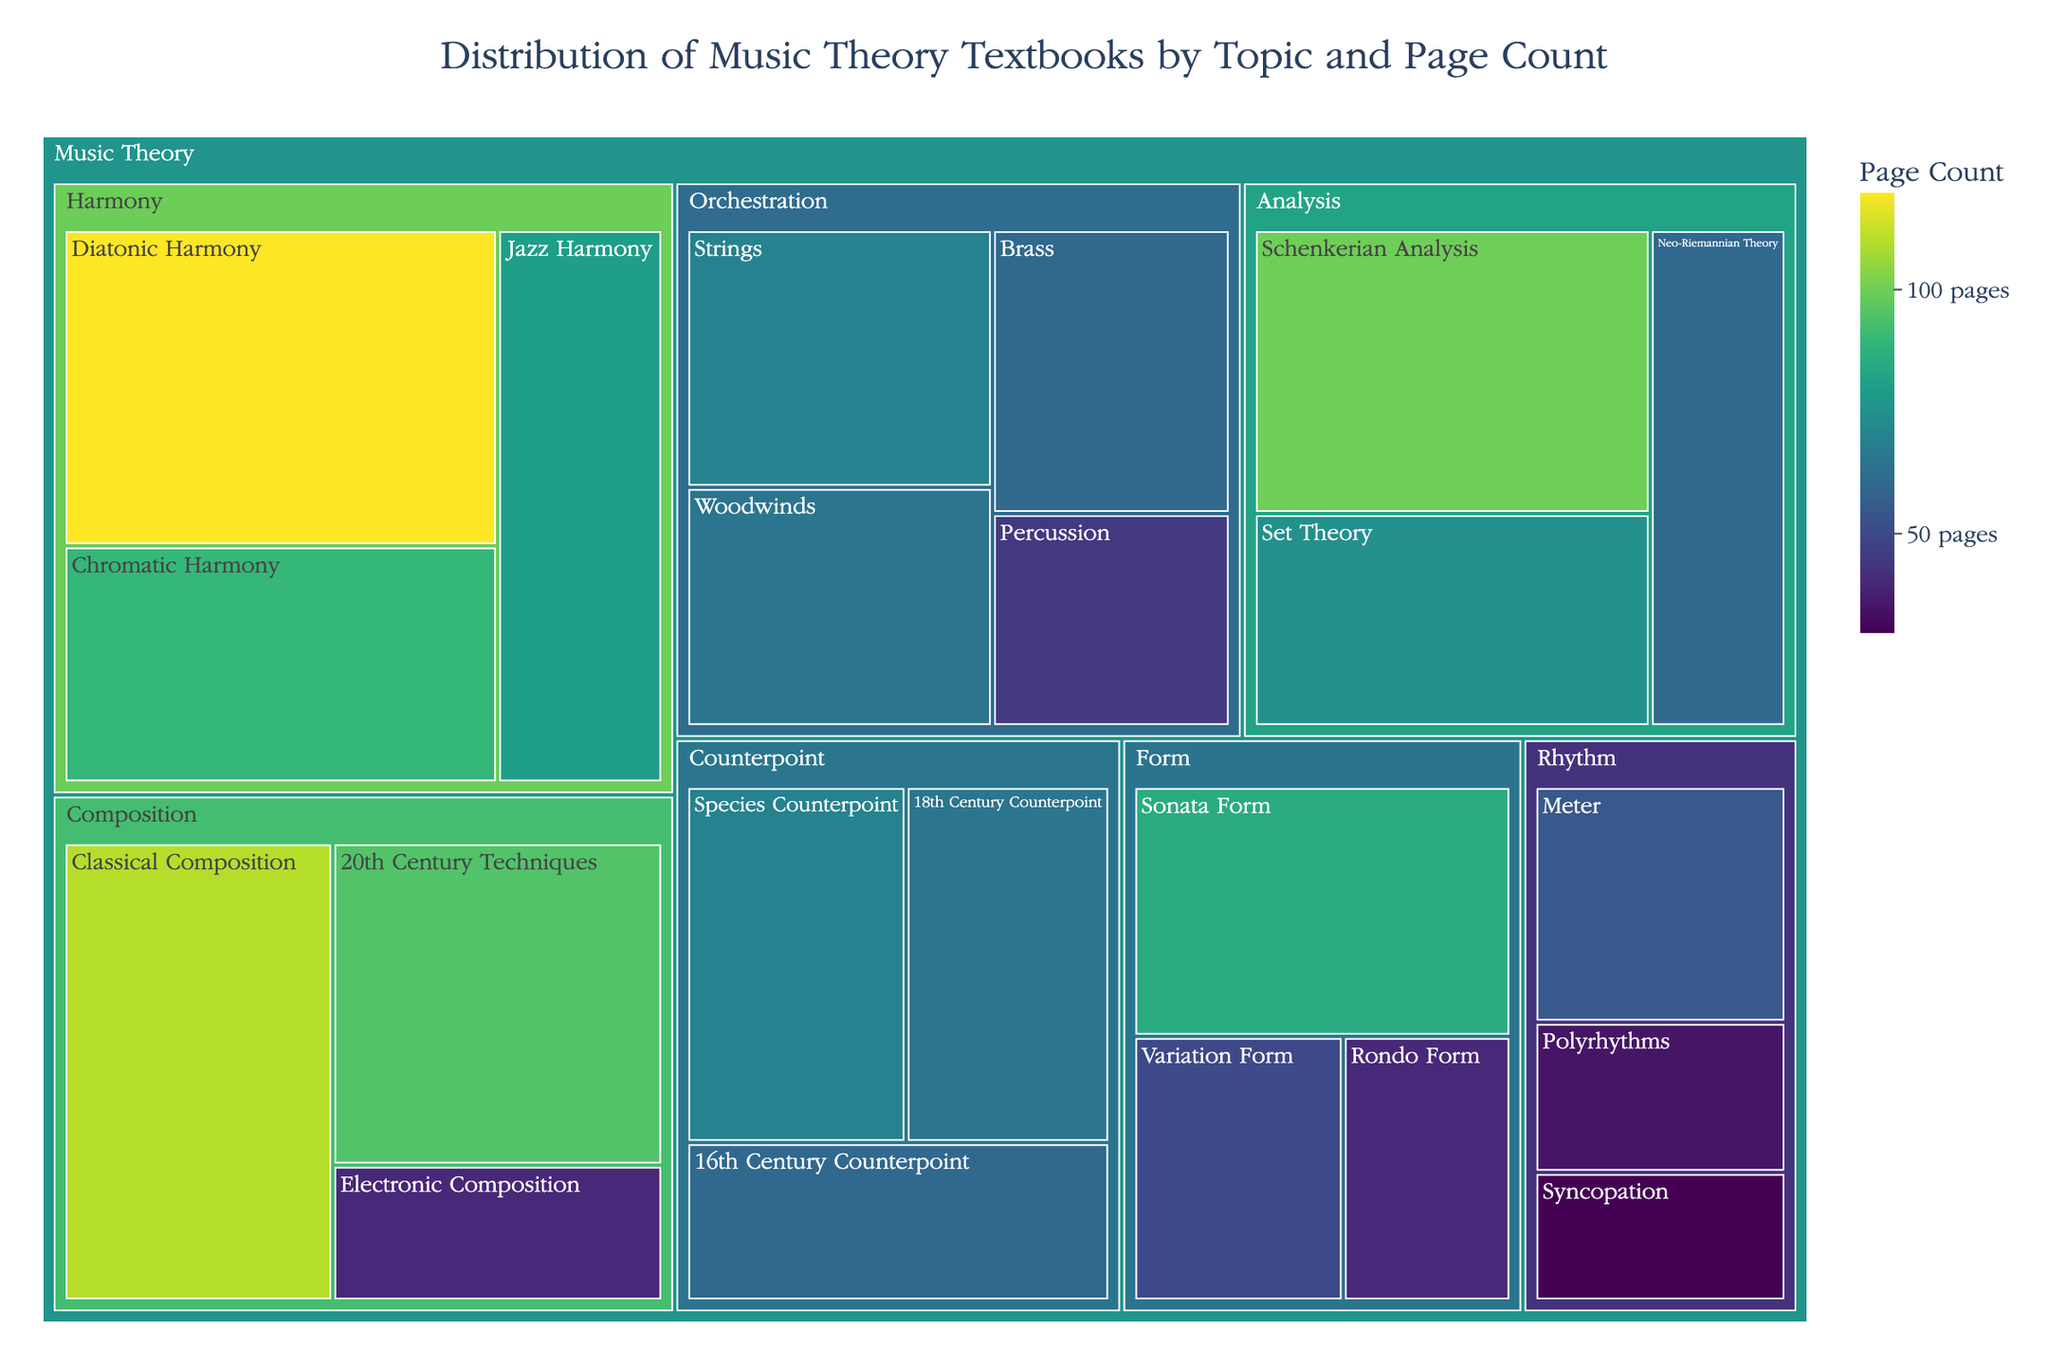What's the largest subtopic in terms of page count? First, look for the largest rectangle in the treemap. The largest one corresponds to "Diatonic Harmony" under the "Harmony" topic with 120 pages.
Answer: Diatonic Harmony Sum the page counts for all subtopics under "Harmony". Identify all subtopics under "Harmony". Add their page counts: 120 (Diatonic Harmony) + 90 (Chromatic Harmony) + 80 (Jazz Harmony) = 290 pages.
Answer: 290 pages Which subtopic has the fewest pages, and how many pages does it have? Look for the smallest rectangle in the treemap. "Syncopation" under "Rhythm" has the fewest pages, with 30 pages.
Answer: Syncopation, 30 pages Compare the total pages for "Counterpoint" and "Form". Which one has more pages? Sum the pages for each subtopic under "Counterpoint" and "Form". Counterpoint: 70 + 60 + 65 = 195 pages, Form: 85 + 40 + 50 = 175 pages. Counterpoint has more pages.
Answer: Counterpoint What is the average page count for subtopics under "Analysis"? Identify subtopics under "Analysis" and their page counts. Sum them up: 100 + 75 + 60 = 235 pages. There are 3 subtopics, so average = 235 / 3 = 78.33 pages.
Answer: 78.33 pages How many subtopics have more than 100 pages? Which are they? Identify items with more than 100 pages. The subtopics are "Diatonic Harmony" (120 pages) and "Classical Composition" (110 pages), so two subtopics.
Answer: Two, Diatonic Harmony and Classical Composition What is the total number of pages for "Orchestration"? Add the pages for each subtopic under "Orchestration": 70 (Strings) + 65 (Woodwinds) + 60 (Brass) + 45 (Percussion) = 240 pages.
Answer: 240 pages Which topic has the second highest total page count? Compare the total pages for all topics. 
Harmony: 290 pages, 
Counterpoint: 195 pages, 
Form: 175 pages, 
Rhythm: 120 pages, 
Orchestration: 240 pages, 
Analysis: 235 pages, 
Composition: 245 pages. 
Composition is the second highest.
Answer: Composition Which topic has more pages: "Rhythm" or "Analysis"? Sum pages for each subtopic under both topics. Rhythm: 55 + 30 + 35 = 120 pages, Analysis: 100 + 75 + 60 = 235 pages. Analysis has more pages.
Answer: Analysis How many subtopics have between 60 and 70 pages? Which are they? Identify subtopics within this range. 
"16th Century Counterpoint" (60 pages), 
"18th Century Counterpoint" (65 pages), 
"Brass" (60 pages), 
"Woodwinds" (65 pages), 
"Neo-Riemannian Theory" (60 pages).
There are five subtopics.
Answer: Five, 16th Century Counterpoint, 18th Century Counterpoint, Brass, Woodwinds, and Neo-Riemannian Theory 